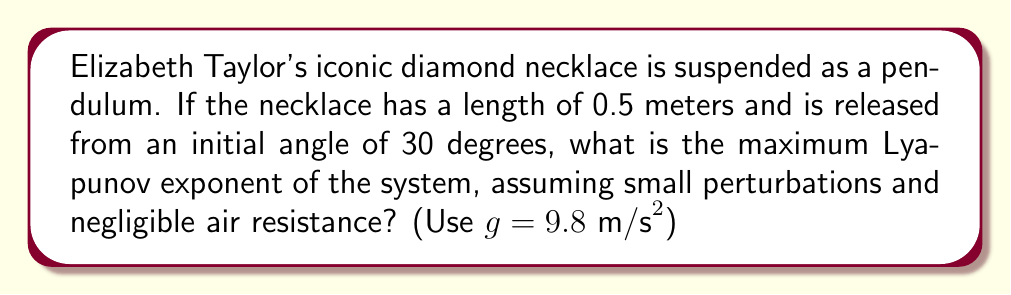Give your solution to this math problem. To find the maximum Lyapunov exponent for the chaotic motion of Elizabeth Taylor's diamond necklace pendulum, we'll follow these steps:

1) For small angles, the equation of motion for a simple pendulum is:

   $$\frac{d^2\theta}{dt^2} + \frac{g}{L}\sin\theta \approx 0$$

   where $\theta$ is the angle, $t$ is time, $g$ is gravitational acceleration, and $L$ is the pendulum length.

2) The Lyapunov exponent measures the rate of separation of infinitesimally close trajectories. For a simple pendulum, it's related to the natural frequency:

   $$\omega_0 = \sqrt{\frac{g}{L}}$$

3) Calculate $\omega_0$ using the given values:

   $$\omega_0 = \sqrt{\frac{9.8 \text{ m/s}^2}{0.5 \text{ m}}} = \sqrt{19.6} \approx 4.427 \text{ rad/s}$$

4) For small perturbations, the maximum Lyapunov exponent ($\lambda_{max}$) is approximately equal to $\omega_0$:

   $$\lambda_{max} \approx \omega_0 \approx 4.427 \text{ s}^{-1}$$

5) This positive Lyapunov exponent indicates that the system is sensitive to initial conditions, a hallmark of chaotic behavior.

Note: In reality, a diamond necklace pendulum would exhibit more complex behavior due to its non-rigid nature and air resistance, but this simplified model gives us insight into its chaotic tendencies.
Answer: $4.427 \text{ s}^{-1}$ 